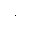Convert formula to latex. <formula><loc_0><loc_0><loc_500><loc_500>\cdot</formula> 